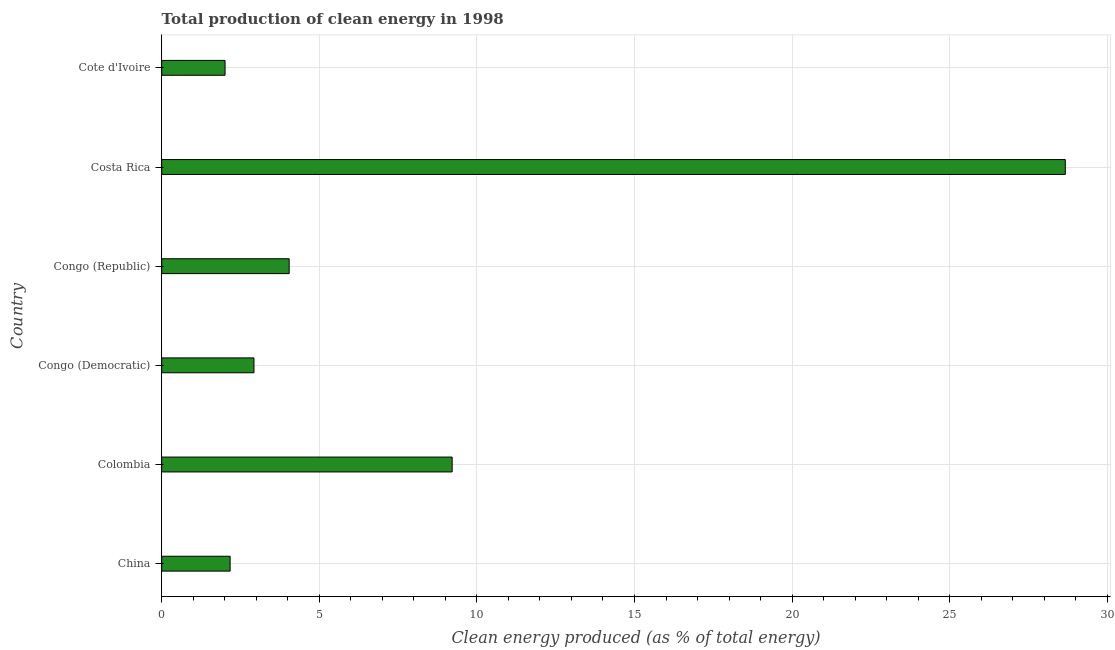Does the graph contain grids?
Your response must be concise. Yes. What is the title of the graph?
Give a very brief answer. Total production of clean energy in 1998. What is the label or title of the X-axis?
Your response must be concise. Clean energy produced (as % of total energy). What is the production of clean energy in Congo (Democratic)?
Keep it short and to the point. 2.93. Across all countries, what is the maximum production of clean energy?
Your answer should be very brief. 28.67. Across all countries, what is the minimum production of clean energy?
Your answer should be very brief. 2.01. In which country was the production of clean energy maximum?
Keep it short and to the point. Costa Rica. In which country was the production of clean energy minimum?
Provide a short and direct response. Cote d'Ivoire. What is the sum of the production of clean energy?
Your answer should be compact. 49.04. What is the difference between the production of clean energy in Colombia and Costa Rica?
Provide a succinct answer. -19.45. What is the average production of clean energy per country?
Give a very brief answer. 8.17. What is the median production of clean energy?
Your response must be concise. 3.49. What is the ratio of the production of clean energy in Colombia to that in Cote d'Ivoire?
Offer a very short reply. 4.58. Is the production of clean energy in China less than that in Congo (Democratic)?
Offer a terse response. Yes. What is the difference between the highest and the second highest production of clean energy?
Offer a terse response. 19.45. Is the sum of the production of clean energy in Colombia and Congo (Democratic) greater than the maximum production of clean energy across all countries?
Offer a very short reply. No. What is the difference between the highest and the lowest production of clean energy?
Provide a short and direct response. 26.66. In how many countries, is the production of clean energy greater than the average production of clean energy taken over all countries?
Offer a terse response. 2. How many bars are there?
Provide a short and direct response. 6. Are all the bars in the graph horizontal?
Provide a succinct answer. Yes. How many countries are there in the graph?
Offer a terse response. 6. What is the Clean energy produced (as % of total energy) in China?
Give a very brief answer. 2.17. What is the Clean energy produced (as % of total energy) of Colombia?
Your response must be concise. 9.22. What is the Clean energy produced (as % of total energy) of Congo (Democratic)?
Provide a succinct answer. 2.93. What is the Clean energy produced (as % of total energy) of Congo (Republic)?
Make the answer very short. 4.04. What is the Clean energy produced (as % of total energy) in Costa Rica?
Ensure brevity in your answer.  28.67. What is the Clean energy produced (as % of total energy) in Cote d'Ivoire?
Offer a terse response. 2.01. What is the difference between the Clean energy produced (as % of total energy) in China and Colombia?
Provide a short and direct response. -7.04. What is the difference between the Clean energy produced (as % of total energy) in China and Congo (Democratic)?
Your answer should be very brief. -0.76. What is the difference between the Clean energy produced (as % of total energy) in China and Congo (Republic)?
Your response must be concise. -1.87. What is the difference between the Clean energy produced (as % of total energy) in China and Costa Rica?
Offer a terse response. -26.5. What is the difference between the Clean energy produced (as % of total energy) in China and Cote d'Ivoire?
Make the answer very short. 0.16. What is the difference between the Clean energy produced (as % of total energy) in Colombia and Congo (Democratic)?
Your answer should be very brief. 6.29. What is the difference between the Clean energy produced (as % of total energy) in Colombia and Congo (Republic)?
Keep it short and to the point. 5.17. What is the difference between the Clean energy produced (as % of total energy) in Colombia and Costa Rica?
Provide a short and direct response. -19.45. What is the difference between the Clean energy produced (as % of total energy) in Colombia and Cote d'Ivoire?
Your response must be concise. 7.21. What is the difference between the Clean energy produced (as % of total energy) in Congo (Democratic) and Congo (Republic)?
Give a very brief answer. -1.12. What is the difference between the Clean energy produced (as % of total energy) in Congo (Democratic) and Costa Rica?
Provide a succinct answer. -25.74. What is the difference between the Clean energy produced (as % of total energy) in Congo (Democratic) and Cote d'Ivoire?
Your answer should be compact. 0.92. What is the difference between the Clean energy produced (as % of total energy) in Congo (Republic) and Costa Rica?
Your answer should be compact. -24.63. What is the difference between the Clean energy produced (as % of total energy) in Congo (Republic) and Cote d'Ivoire?
Provide a short and direct response. 2.03. What is the difference between the Clean energy produced (as % of total energy) in Costa Rica and Cote d'Ivoire?
Make the answer very short. 26.66. What is the ratio of the Clean energy produced (as % of total energy) in China to that in Colombia?
Your response must be concise. 0.24. What is the ratio of the Clean energy produced (as % of total energy) in China to that in Congo (Democratic)?
Provide a short and direct response. 0.74. What is the ratio of the Clean energy produced (as % of total energy) in China to that in Congo (Republic)?
Give a very brief answer. 0.54. What is the ratio of the Clean energy produced (as % of total energy) in China to that in Costa Rica?
Give a very brief answer. 0.08. What is the ratio of the Clean energy produced (as % of total energy) in China to that in Cote d'Ivoire?
Your response must be concise. 1.08. What is the ratio of the Clean energy produced (as % of total energy) in Colombia to that in Congo (Democratic)?
Offer a very short reply. 3.15. What is the ratio of the Clean energy produced (as % of total energy) in Colombia to that in Congo (Republic)?
Your answer should be very brief. 2.28. What is the ratio of the Clean energy produced (as % of total energy) in Colombia to that in Costa Rica?
Keep it short and to the point. 0.32. What is the ratio of the Clean energy produced (as % of total energy) in Colombia to that in Cote d'Ivoire?
Ensure brevity in your answer.  4.58. What is the ratio of the Clean energy produced (as % of total energy) in Congo (Democratic) to that in Congo (Republic)?
Keep it short and to the point. 0.72. What is the ratio of the Clean energy produced (as % of total energy) in Congo (Democratic) to that in Costa Rica?
Offer a terse response. 0.1. What is the ratio of the Clean energy produced (as % of total energy) in Congo (Democratic) to that in Cote d'Ivoire?
Keep it short and to the point. 1.46. What is the ratio of the Clean energy produced (as % of total energy) in Congo (Republic) to that in Costa Rica?
Give a very brief answer. 0.14. What is the ratio of the Clean energy produced (as % of total energy) in Congo (Republic) to that in Cote d'Ivoire?
Offer a terse response. 2.01. What is the ratio of the Clean energy produced (as % of total energy) in Costa Rica to that in Cote d'Ivoire?
Ensure brevity in your answer.  14.26. 